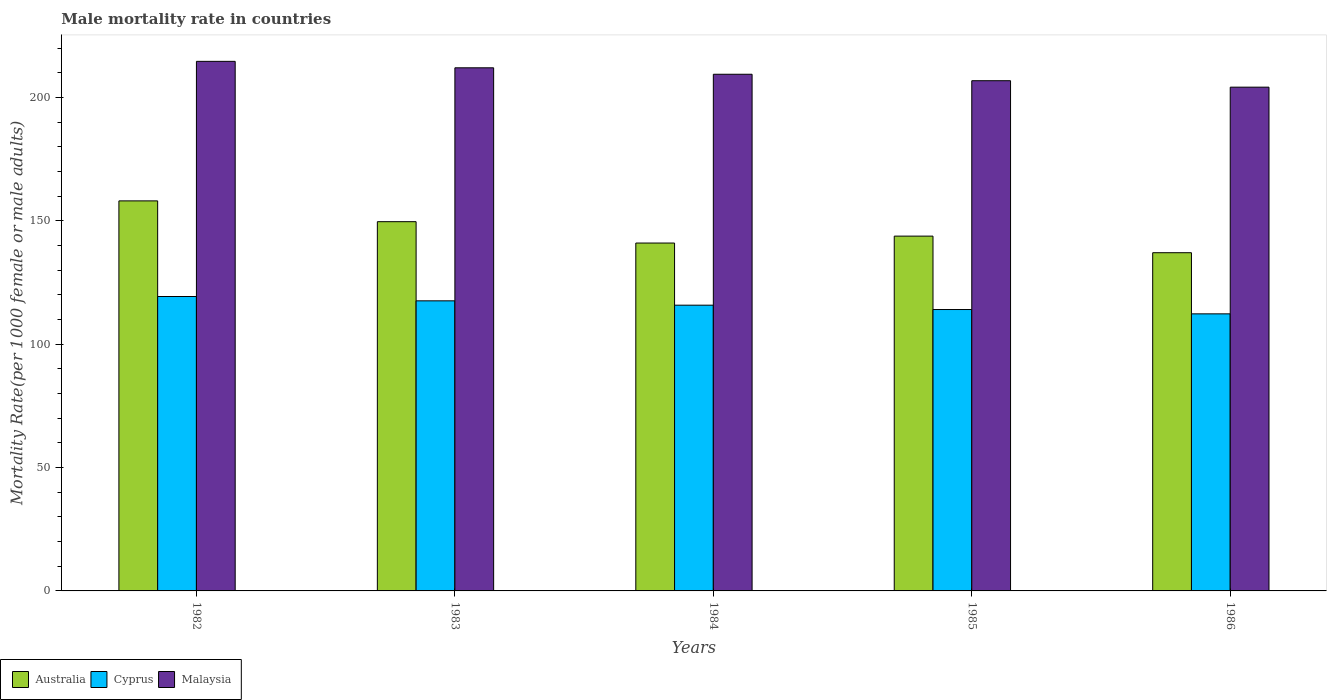What is the label of the 1st group of bars from the left?
Keep it short and to the point. 1982. What is the male mortality rate in Cyprus in 1984?
Ensure brevity in your answer.  115.84. Across all years, what is the maximum male mortality rate in Australia?
Offer a very short reply. 158.12. Across all years, what is the minimum male mortality rate in Cyprus?
Your response must be concise. 112.32. What is the total male mortality rate in Australia in the graph?
Provide a succinct answer. 729.78. What is the difference between the male mortality rate in Cyprus in 1982 and that in 1985?
Keep it short and to the point. 5.28. What is the difference between the male mortality rate in Malaysia in 1986 and the male mortality rate in Australia in 1983?
Provide a succinct answer. 54.53. What is the average male mortality rate in Australia per year?
Give a very brief answer. 145.96. In the year 1985, what is the difference between the male mortality rate in Malaysia and male mortality rate in Cyprus?
Your answer should be compact. 92.76. In how many years, is the male mortality rate in Cyprus greater than 190?
Make the answer very short. 0. What is the ratio of the male mortality rate in Cyprus in 1982 to that in 1986?
Keep it short and to the point. 1.06. Is the male mortality rate in Australia in 1982 less than that in 1985?
Your answer should be very brief. No. Is the difference between the male mortality rate in Malaysia in 1982 and 1984 greater than the difference between the male mortality rate in Cyprus in 1982 and 1984?
Give a very brief answer. Yes. What is the difference between the highest and the second highest male mortality rate in Cyprus?
Offer a terse response. 1.76. What is the difference between the highest and the lowest male mortality rate in Malaysia?
Make the answer very short. 10.46. In how many years, is the male mortality rate in Malaysia greater than the average male mortality rate in Malaysia taken over all years?
Make the answer very short. 3. What does the 3rd bar from the left in 1985 represents?
Your answer should be very brief. Malaysia. What does the 3rd bar from the right in 1984 represents?
Your answer should be compact. Australia. Is it the case that in every year, the sum of the male mortality rate in Australia and male mortality rate in Cyprus is greater than the male mortality rate in Malaysia?
Offer a very short reply. Yes. How many bars are there?
Your answer should be compact. 15. Are all the bars in the graph horizontal?
Your response must be concise. No. Are the values on the major ticks of Y-axis written in scientific E-notation?
Provide a short and direct response. No. Does the graph contain any zero values?
Your answer should be compact. No. What is the title of the graph?
Provide a succinct answer. Male mortality rate in countries. What is the label or title of the X-axis?
Your answer should be compact. Years. What is the label or title of the Y-axis?
Make the answer very short. Mortality Rate(per 1000 female or male adults). What is the Mortality Rate(per 1000 female or male adults) in Australia in 1982?
Your response must be concise. 158.12. What is the Mortality Rate(per 1000 female or male adults) of Cyprus in 1982?
Your answer should be very brief. 119.36. What is the Mortality Rate(per 1000 female or male adults) in Malaysia in 1982?
Offer a terse response. 214.68. What is the Mortality Rate(per 1000 female or male adults) in Australia in 1983?
Offer a very short reply. 149.69. What is the Mortality Rate(per 1000 female or male adults) in Cyprus in 1983?
Provide a succinct answer. 117.6. What is the Mortality Rate(per 1000 female or male adults) of Malaysia in 1983?
Give a very brief answer. 212.07. What is the Mortality Rate(per 1000 female or male adults) of Australia in 1984?
Offer a very short reply. 141.03. What is the Mortality Rate(per 1000 female or male adults) of Cyprus in 1984?
Ensure brevity in your answer.  115.84. What is the Mortality Rate(per 1000 female or male adults) of Malaysia in 1984?
Keep it short and to the point. 209.45. What is the Mortality Rate(per 1000 female or male adults) in Australia in 1985?
Offer a terse response. 143.83. What is the Mortality Rate(per 1000 female or male adults) in Cyprus in 1985?
Make the answer very short. 114.08. What is the Mortality Rate(per 1000 female or male adults) of Malaysia in 1985?
Keep it short and to the point. 206.84. What is the Mortality Rate(per 1000 female or male adults) in Australia in 1986?
Your answer should be very brief. 137.11. What is the Mortality Rate(per 1000 female or male adults) in Cyprus in 1986?
Your answer should be compact. 112.32. What is the Mortality Rate(per 1000 female or male adults) in Malaysia in 1986?
Offer a very short reply. 204.22. Across all years, what is the maximum Mortality Rate(per 1000 female or male adults) in Australia?
Offer a terse response. 158.12. Across all years, what is the maximum Mortality Rate(per 1000 female or male adults) of Cyprus?
Provide a short and direct response. 119.36. Across all years, what is the maximum Mortality Rate(per 1000 female or male adults) of Malaysia?
Make the answer very short. 214.68. Across all years, what is the minimum Mortality Rate(per 1000 female or male adults) in Australia?
Make the answer very short. 137.11. Across all years, what is the minimum Mortality Rate(per 1000 female or male adults) in Cyprus?
Give a very brief answer. 112.32. Across all years, what is the minimum Mortality Rate(per 1000 female or male adults) in Malaysia?
Provide a short and direct response. 204.22. What is the total Mortality Rate(per 1000 female or male adults) in Australia in the graph?
Your response must be concise. 729.78. What is the total Mortality Rate(per 1000 female or male adults) of Cyprus in the graph?
Your response must be concise. 579.19. What is the total Mortality Rate(per 1000 female or male adults) in Malaysia in the graph?
Offer a very short reply. 1047.25. What is the difference between the Mortality Rate(per 1000 female or male adults) in Australia in 1982 and that in 1983?
Give a very brief answer. 8.43. What is the difference between the Mortality Rate(per 1000 female or male adults) of Cyprus in 1982 and that in 1983?
Give a very brief answer. 1.76. What is the difference between the Mortality Rate(per 1000 female or male adults) of Malaysia in 1982 and that in 1983?
Provide a succinct answer. 2.62. What is the difference between the Mortality Rate(per 1000 female or male adults) in Australia in 1982 and that in 1984?
Provide a succinct answer. 17.09. What is the difference between the Mortality Rate(per 1000 female or male adults) of Cyprus in 1982 and that in 1984?
Keep it short and to the point. 3.52. What is the difference between the Mortality Rate(per 1000 female or male adults) in Malaysia in 1982 and that in 1984?
Offer a terse response. 5.23. What is the difference between the Mortality Rate(per 1000 female or male adults) in Australia in 1982 and that in 1985?
Your answer should be very brief. 14.29. What is the difference between the Mortality Rate(per 1000 female or male adults) of Cyprus in 1982 and that in 1985?
Make the answer very short. 5.28. What is the difference between the Mortality Rate(per 1000 female or male adults) of Malaysia in 1982 and that in 1985?
Make the answer very short. 7.85. What is the difference between the Mortality Rate(per 1000 female or male adults) in Australia in 1982 and that in 1986?
Offer a terse response. 21.01. What is the difference between the Mortality Rate(per 1000 female or male adults) in Cyprus in 1982 and that in 1986?
Provide a short and direct response. 7.04. What is the difference between the Mortality Rate(per 1000 female or male adults) of Malaysia in 1982 and that in 1986?
Provide a short and direct response. 10.46. What is the difference between the Mortality Rate(per 1000 female or male adults) of Australia in 1983 and that in 1984?
Provide a succinct answer. 8.66. What is the difference between the Mortality Rate(per 1000 female or male adults) of Cyprus in 1983 and that in 1984?
Offer a terse response. 1.76. What is the difference between the Mortality Rate(per 1000 female or male adults) in Malaysia in 1983 and that in 1984?
Your answer should be compact. 2.62. What is the difference between the Mortality Rate(per 1000 female or male adults) of Australia in 1983 and that in 1985?
Your response must be concise. 5.86. What is the difference between the Mortality Rate(per 1000 female or male adults) of Cyprus in 1983 and that in 1985?
Provide a short and direct response. 3.52. What is the difference between the Mortality Rate(per 1000 female or male adults) of Malaysia in 1983 and that in 1985?
Give a very brief answer. 5.23. What is the difference between the Mortality Rate(per 1000 female or male adults) in Australia in 1983 and that in 1986?
Keep it short and to the point. 12.58. What is the difference between the Mortality Rate(per 1000 female or male adults) of Cyprus in 1983 and that in 1986?
Offer a terse response. 5.28. What is the difference between the Mortality Rate(per 1000 female or male adults) of Malaysia in 1983 and that in 1986?
Your response must be concise. 7.85. What is the difference between the Mortality Rate(per 1000 female or male adults) of Australia in 1984 and that in 1985?
Provide a succinct answer. -2.8. What is the difference between the Mortality Rate(per 1000 female or male adults) in Cyprus in 1984 and that in 1985?
Ensure brevity in your answer.  1.76. What is the difference between the Mortality Rate(per 1000 female or male adults) of Malaysia in 1984 and that in 1985?
Your answer should be very brief. 2.62. What is the difference between the Mortality Rate(per 1000 female or male adults) of Australia in 1984 and that in 1986?
Ensure brevity in your answer.  3.92. What is the difference between the Mortality Rate(per 1000 female or male adults) of Cyprus in 1984 and that in 1986?
Make the answer very short. 3.52. What is the difference between the Mortality Rate(per 1000 female or male adults) in Malaysia in 1984 and that in 1986?
Your answer should be compact. 5.23. What is the difference between the Mortality Rate(per 1000 female or male adults) of Australia in 1985 and that in 1986?
Your answer should be very brief. 6.72. What is the difference between the Mortality Rate(per 1000 female or male adults) in Cyprus in 1985 and that in 1986?
Provide a short and direct response. 1.76. What is the difference between the Mortality Rate(per 1000 female or male adults) of Malaysia in 1985 and that in 1986?
Provide a short and direct response. 2.62. What is the difference between the Mortality Rate(per 1000 female or male adults) in Australia in 1982 and the Mortality Rate(per 1000 female or male adults) in Cyprus in 1983?
Keep it short and to the point. 40.52. What is the difference between the Mortality Rate(per 1000 female or male adults) in Australia in 1982 and the Mortality Rate(per 1000 female or male adults) in Malaysia in 1983?
Provide a succinct answer. -53.95. What is the difference between the Mortality Rate(per 1000 female or male adults) of Cyprus in 1982 and the Mortality Rate(per 1000 female or male adults) of Malaysia in 1983?
Offer a very short reply. -92.71. What is the difference between the Mortality Rate(per 1000 female or male adults) of Australia in 1982 and the Mortality Rate(per 1000 female or male adults) of Cyprus in 1984?
Keep it short and to the point. 42.28. What is the difference between the Mortality Rate(per 1000 female or male adults) in Australia in 1982 and the Mortality Rate(per 1000 female or male adults) in Malaysia in 1984?
Your answer should be very brief. -51.33. What is the difference between the Mortality Rate(per 1000 female or male adults) of Cyprus in 1982 and the Mortality Rate(per 1000 female or male adults) of Malaysia in 1984?
Your answer should be compact. -90.1. What is the difference between the Mortality Rate(per 1000 female or male adults) in Australia in 1982 and the Mortality Rate(per 1000 female or male adults) in Cyprus in 1985?
Provide a short and direct response. 44.04. What is the difference between the Mortality Rate(per 1000 female or male adults) in Australia in 1982 and the Mortality Rate(per 1000 female or male adults) in Malaysia in 1985?
Your answer should be compact. -48.72. What is the difference between the Mortality Rate(per 1000 female or male adults) in Cyprus in 1982 and the Mortality Rate(per 1000 female or male adults) in Malaysia in 1985?
Your response must be concise. -87.48. What is the difference between the Mortality Rate(per 1000 female or male adults) in Australia in 1982 and the Mortality Rate(per 1000 female or male adults) in Cyprus in 1986?
Your answer should be very brief. 45.8. What is the difference between the Mortality Rate(per 1000 female or male adults) in Australia in 1982 and the Mortality Rate(per 1000 female or male adults) in Malaysia in 1986?
Offer a very short reply. -46.1. What is the difference between the Mortality Rate(per 1000 female or male adults) in Cyprus in 1982 and the Mortality Rate(per 1000 female or male adults) in Malaysia in 1986?
Ensure brevity in your answer.  -84.86. What is the difference between the Mortality Rate(per 1000 female or male adults) of Australia in 1983 and the Mortality Rate(per 1000 female or male adults) of Cyprus in 1984?
Offer a terse response. 33.85. What is the difference between the Mortality Rate(per 1000 female or male adults) of Australia in 1983 and the Mortality Rate(per 1000 female or male adults) of Malaysia in 1984?
Make the answer very short. -59.76. What is the difference between the Mortality Rate(per 1000 female or male adults) in Cyprus in 1983 and the Mortality Rate(per 1000 female or male adults) in Malaysia in 1984?
Make the answer very short. -91.86. What is the difference between the Mortality Rate(per 1000 female or male adults) of Australia in 1983 and the Mortality Rate(per 1000 female or male adults) of Cyprus in 1985?
Your answer should be compact. 35.61. What is the difference between the Mortality Rate(per 1000 female or male adults) of Australia in 1983 and the Mortality Rate(per 1000 female or male adults) of Malaysia in 1985?
Keep it short and to the point. -57.15. What is the difference between the Mortality Rate(per 1000 female or male adults) in Cyprus in 1983 and the Mortality Rate(per 1000 female or male adults) in Malaysia in 1985?
Keep it short and to the point. -89.24. What is the difference between the Mortality Rate(per 1000 female or male adults) in Australia in 1983 and the Mortality Rate(per 1000 female or male adults) in Cyprus in 1986?
Your answer should be very brief. 37.37. What is the difference between the Mortality Rate(per 1000 female or male adults) of Australia in 1983 and the Mortality Rate(per 1000 female or male adults) of Malaysia in 1986?
Your response must be concise. -54.53. What is the difference between the Mortality Rate(per 1000 female or male adults) in Cyprus in 1983 and the Mortality Rate(per 1000 female or male adults) in Malaysia in 1986?
Offer a very short reply. -86.62. What is the difference between the Mortality Rate(per 1000 female or male adults) in Australia in 1984 and the Mortality Rate(per 1000 female or male adults) in Cyprus in 1985?
Ensure brevity in your answer.  26.95. What is the difference between the Mortality Rate(per 1000 female or male adults) in Australia in 1984 and the Mortality Rate(per 1000 female or male adults) in Malaysia in 1985?
Your answer should be very brief. -65.81. What is the difference between the Mortality Rate(per 1000 female or male adults) of Cyprus in 1984 and the Mortality Rate(per 1000 female or male adults) of Malaysia in 1985?
Your answer should be very brief. -91. What is the difference between the Mortality Rate(per 1000 female or male adults) in Australia in 1984 and the Mortality Rate(per 1000 female or male adults) in Cyprus in 1986?
Make the answer very short. 28.71. What is the difference between the Mortality Rate(per 1000 female or male adults) of Australia in 1984 and the Mortality Rate(per 1000 female or male adults) of Malaysia in 1986?
Keep it short and to the point. -63.19. What is the difference between the Mortality Rate(per 1000 female or male adults) of Cyprus in 1984 and the Mortality Rate(per 1000 female or male adults) of Malaysia in 1986?
Make the answer very short. -88.38. What is the difference between the Mortality Rate(per 1000 female or male adults) in Australia in 1985 and the Mortality Rate(per 1000 female or male adults) in Cyprus in 1986?
Your answer should be compact. 31.51. What is the difference between the Mortality Rate(per 1000 female or male adults) of Australia in 1985 and the Mortality Rate(per 1000 female or male adults) of Malaysia in 1986?
Your answer should be compact. -60.39. What is the difference between the Mortality Rate(per 1000 female or male adults) in Cyprus in 1985 and the Mortality Rate(per 1000 female or male adults) in Malaysia in 1986?
Provide a short and direct response. -90.14. What is the average Mortality Rate(per 1000 female or male adults) in Australia per year?
Offer a terse response. 145.96. What is the average Mortality Rate(per 1000 female or male adults) of Cyprus per year?
Your response must be concise. 115.84. What is the average Mortality Rate(per 1000 female or male adults) of Malaysia per year?
Offer a very short reply. 209.45. In the year 1982, what is the difference between the Mortality Rate(per 1000 female or male adults) of Australia and Mortality Rate(per 1000 female or male adults) of Cyprus?
Your answer should be compact. 38.76. In the year 1982, what is the difference between the Mortality Rate(per 1000 female or male adults) of Australia and Mortality Rate(per 1000 female or male adults) of Malaysia?
Keep it short and to the point. -56.56. In the year 1982, what is the difference between the Mortality Rate(per 1000 female or male adults) of Cyprus and Mortality Rate(per 1000 female or male adults) of Malaysia?
Your answer should be very brief. -95.33. In the year 1983, what is the difference between the Mortality Rate(per 1000 female or male adults) in Australia and Mortality Rate(per 1000 female or male adults) in Cyprus?
Your answer should be compact. 32.09. In the year 1983, what is the difference between the Mortality Rate(per 1000 female or male adults) of Australia and Mortality Rate(per 1000 female or male adults) of Malaysia?
Give a very brief answer. -62.38. In the year 1983, what is the difference between the Mortality Rate(per 1000 female or male adults) in Cyprus and Mortality Rate(per 1000 female or male adults) in Malaysia?
Your answer should be compact. -94.47. In the year 1984, what is the difference between the Mortality Rate(per 1000 female or male adults) of Australia and Mortality Rate(per 1000 female or male adults) of Cyprus?
Ensure brevity in your answer.  25.19. In the year 1984, what is the difference between the Mortality Rate(per 1000 female or male adults) of Australia and Mortality Rate(per 1000 female or male adults) of Malaysia?
Offer a very short reply. -68.42. In the year 1984, what is the difference between the Mortality Rate(per 1000 female or male adults) in Cyprus and Mortality Rate(per 1000 female or male adults) in Malaysia?
Provide a short and direct response. -93.61. In the year 1985, what is the difference between the Mortality Rate(per 1000 female or male adults) in Australia and Mortality Rate(per 1000 female or male adults) in Cyprus?
Your answer should be very brief. 29.75. In the year 1985, what is the difference between the Mortality Rate(per 1000 female or male adults) in Australia and Mortality Rate(per 1000 female or male adults) in Malaysia?
Provide a short and direct response. -63. In the year 1985, what is the difference between the Mortality Rate(per 1000 female or male adults) in Cyprus and Mortality Rate(per 1000 female or male adults) in Malaysia?
Provide a short and direct response. -92.76. In the year 1986, what is the difference between the Mortality Rate(per 1000 female or male adults) in Australia and Mortality Rate(per 1000 female or male adults) in Cyprus?
Offer a terse response. 24.79. In the year 1986, what is the difference between the Mortality Rate(per 1000 female or male adults) of Australia and Mortality Rate(per 1000 female or male adults) of Malaysia?
Make the answer very short. -67.11. In the year 1986, what is the difference between the Mortality Rate(per 1000 female or male adults) of Cyprus and Mortality Rate(per 1000 female or male adults) of Malaysia?
Make the answer very short. -91.9. What is the ratio of the Mortality Rate(per 1000 female or male adults) of Australia in 1982 to that in 1983?
Provide a succinct answer. 1.06. What is the ratio of the Mortality Rate(per 1000 female or male adults) in Malaysia in 1982 to that in 1983?
Keep it short and to the point. 1.01. What is the ratio of the Mortality Rate(per 1000 female or male adults) in Australia in 1982 to that in 1984?
Keep it short and to the point. 1.12. What is the ratio of the Mortality Rate(per 1000 female or male adults) of Cyprus in 1982 to that in 1984?
Your response must be concise. 1.03. What is the ratio of the Mortality Rate(per 1000 female or male adults) of Malaysia in 1982 to that in 1984?
Provide a succinct answer. 1.02. What is the ratio of the Mortality Rate(per 1000 female or male adults) of Australia in 1982 to that in 1985?
Your answer should be very brief. 1.1. What is the ratio of the Mortality Rate(per 1000 female or male adults) in Cyprus in 1982 to that in 1985?
Offer a very short reply. 1.05. What is the ratio of the Mortality Rate(per 1000 female or male adults) of Malaysia in 1982 to that in 1985?
Provide a succinct answer. 1.04. What is the ratio of the Mortality Rate(per 1000 female or male adults) of Australia in 1982 to that in 1986?
Your answer should be very brief. 1.15. What is the ratio of the Mortality Rate(per 1000 female or male adults) in Cyprus in 1982 to that in 1986?
Give a very brief answer. 1.06. What is the ratio of the Mortality Rate(per 1000 female or male adults) in Malaysia in 1982 to that in 1986?
Ensure brevity in your answer.  1.05. What is the ratio of the Mortality Rate(per 1000 female or male adults) in Australia in 1983 to that in 1984?
Offer a very short reply. 1.06. What is the ratio of the Mortality Rate(per 1000 female or male adults) in Cyprus in 1983 to that in 1984?
Give a very brief answer. 1.02. What is the ratio of the Mortality Rate(per 1000 female or male adults) in Malaysia in 1983 to that in 1984?
Give a very brief answer. 1.01. What is the ratio of the Mortality Rate(per 1000 female or male adults) of Australia in 1983 to that in 1985?
Ensure brevity in your answer.  1.04. What is the ratio of the Mortality Rate(per 1000 female or male adults) in Cyprus in 1983 to that in 1985?
Ensure brevity in your answer.  1.03. What is the ratio of the Mortality Rate(per 1000 female or male adults) of Malaysia in 1983 to that in 1985?
Offer a terse response. 1.03. What is the ratio of the Mortality Rate(per 1000 female or male adults) of Australia in 1983 to that in 1986?
Your answer should be very brief. 1.09. What is the ratio of the Mortality Rate(per 1000 female or male adults) of Cyprus in 1983 to that in 1986?
Provide a succinct answer. 1.05. What is the ratio of the Mortality Rate(per 1000 female or male adults) in Malaysia in 1983 to that in 1986?
Make the answer very short. 1.04. What is the ratio of the Mortality Rate(per 1000 female or male adults) of Australia in 1984 to that in 1985?
Ensure brevity in your answer.  0.98. What is the ratio of the Mortality Rate(per 1000 female or male adults) of Cyprus in 1984 to that in 1985?
Your answer should be compact. 1.02. What is the ratio of the Mortality Rate(per 1000 female or male adults) of Malaysia in 1984 to that in 1985?
Keep it short and to the point. 1.01. What is the ratio of the Mortality Rate(per 1000 female or male adults) of Australia in 1984 to that in 1986?
Your response must be concise. 1.03. What is the ratio of the Mortality Rate(per 1000 female or male adults) of Cyprus in 1984 to that in 1986?
Your response must be concise. 1.03. What is the ratio of the Mortality Rate(per 1000 female or male adults) of Malaysia in 1984 to that in 1986?
Ensure brevity in your answer.  1.03. What is the ratio of the Mortality Rate(per 1000 female or male adults) in Australia in 1985 to that in 1986?
Keep it short and to the point. 1.05. What is the ratio of the Mortality Rate(per 1000 female or male adults) in Cyprus in 1985 to that in 1986?
Ensure brevity in your answer.  1.02. What is the ratio of the Mortality Rate(per 1000 female or male adults) of Malaysia in 1985 to that in 1986?
Make the answer very short. 1.01. What is the difference between the highest and the second highest Mortality Rate(per 1000 female or male adults) in Australia?
Give a very brief answer. 8.43. What is the difference between the highest and the second highest Mortality Rate(per 1000 female or male adults) of Cyprus?
Keep it short and to the point. 1.76. What is the difference between the highest and the second highest Mortality Rate(per 1000 female or male adults) in Malaysia?
Offer a very short reply. 2.62. What is the difference between the highest and the lowest Mortality Rate(per 1000 female or male adults) in Australia?
Your response must be concise. 21.01. What is the difference between the highest and the lowest Mortality Rate(per 1000 female or male adults) of Cyprus?
Your answer should be compact. 7.04. What is the difference between the highest and the lowest Mortality Rate(per 1000 female or male adults) in Malaysia?
Make the answer very short. 10.46. 